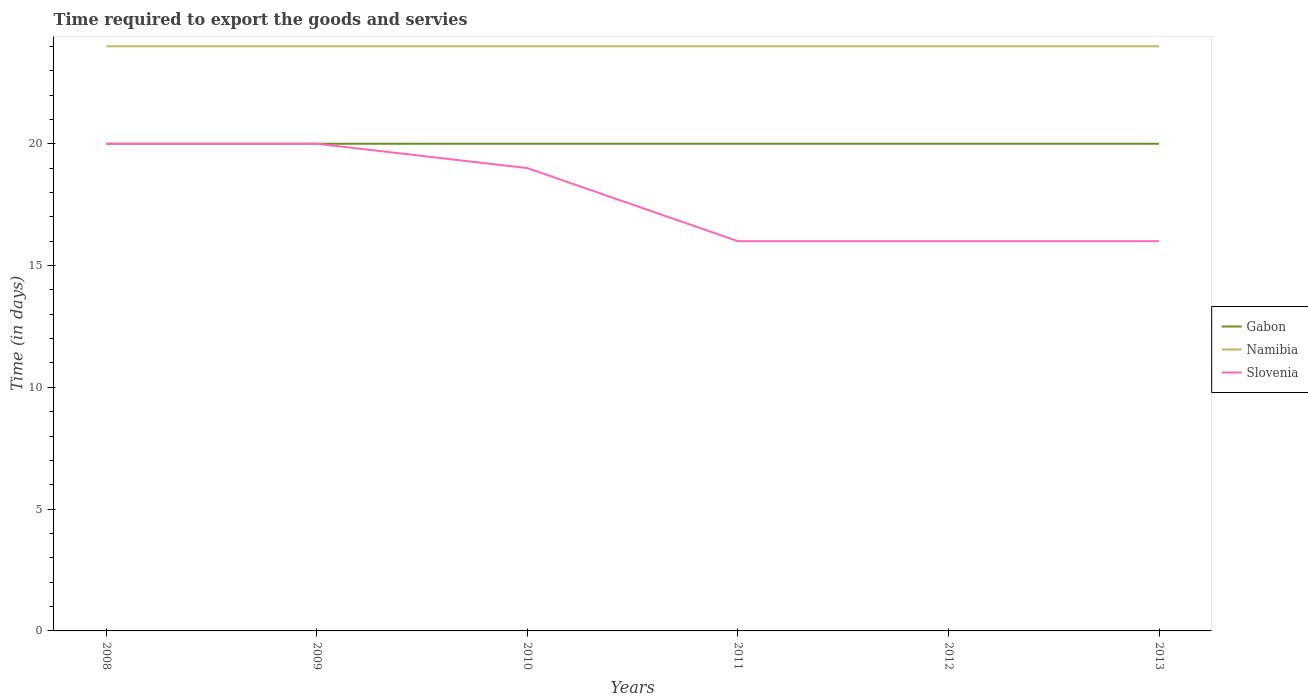Does the line corresponding to Namibia intersect with the line corresponding to Gabon?
Offer a very short reply. No. Is the number of lines equal to the number of legend labels?
Your answer should be compact. Yes. Across all years, what is the maximum number of days required to export the goods and services in Namibia?
Give a very brief answer. 24. In which year was the number of days required to export the goods and services in Namibia maximum?
Your response must be concise. 2008. What is the difference between the highest and the second highest number of days required to export the goods and services in Slovenia?
Make the answer very short. 4. How many years are there in the graph?
Offer a very short reply. 6. Does the graph contain any zero values?
Your answer should be compact. No. Where does the legend appear in the graph?
Make the answer very short. Center right. How many legend labels are there?
Provide a short and direct response. 3. What is the title of the graph?
Offer a terse response. Time required to export the goods and servies. Does "Guinea-Bissau" appear as one of the legend labels in the graph?
Make the answer very short. No. What is the label or title of the Y-axis?
Provide a succinct answer. Time (in days). What is the Time (in days) in Slovenia in 2008?
Your answer should be very brief. 20. What is the Time (in days) of Gabon in 2009?
Provide a succinct answer. 20. What is the Time (in days) of Namibia in 2009?
Your answer should be compact. 24. What is the Time (in days) in Slovenia in 2009?
Your answer should be very brief. 20. What is the Time (in days) in Gabon in 2011?
Make the answer very short. 20. What is the Time (in days) in Slovenia in 2011?
Offer a very short reply. 16. What is the Time (in days) of Namibia in 2012?
Ensure brevity in your answer.  24. What is the Time (in days) in Slovenia in 2012?
Offer a terse response. 16. What is the Time (in days) in Namibia in 2013?
Offer a very short reply. 24. What is the Time (in days) of Slovenia in 2013?
Keep it short and to the point. 16. Across all years, what is the maximum Time (in days) of Namibia?
Your answer should be very brief. 24. Across all years, what is the minimum Time (in days) in Gabon?
Ensure brevity in your answer.  20. What is the total Time (in days) of Gabon in the graph?
Your response must be concise. 120. What is the total Time (in days) of Namibia in the graph?
Give a very brief answer. 144. What is the total Time (in days) in Slovenia in the graph?
Provide a short and direct response. 107. What is the difference between the Time (in days) in Gabon in 2008 and that in 2009?
Offer a terse response. 0. What is the difference between the Time (in days) of Slovenia in 2008 and that in 2009?
Offer a very short reply. 0. What is the difference between the Time (in days) in Gabon in 2008 and that in 2010?
Provide a short and direct response. 0. What is the difference between the Time (in days) of Namibia in 2008 and that in 2010?
Ensure brevity in your answer.  0. What is the difference between the Time (in days) in Namibia in 2008 and that in 2012?
Make the answer very short. 0. What is the difference between the Time (in days) in Slovenia in 2008 and that in 2013?
Offer a terse response. 4. What is the difference between the Time (in days) of Gabon in 2009 and that in 2010?
Keep it short and to the point. 0. What is the difference between the Time (in days) of Namibia in 2009 and that in 2010?
Make the answer very short. 0. What is the difference between the Time (in days) of Gabon in 2009 and that in 2011?
Give a very brief answer. 0. What is the difference between the Time (in days) of Gabon in 2009 and that in 2012?
Make the answer very short. 0. What is the difference between the Time (in days) in Slovenia in 2009 and that in 2012?
Give a very brief answer. 4. What is the difference between the Time (in days) in Gabon in 2009 and that in 2013?
Offer a very short reply. 0. What is the difference between the Time (in days) in Slovenia in 2009 and that in 2013?
Offer a very short reply. 4. What is the difference between the Time (in days) in Gabon in 2010 and that in 2012?
Provide a short and direct response. 0. What is the difference between the Time (in days) of Namibia in 2010 and that in 2012?
Your answer should be very brief. 0. What is the difference between the Time (in days) in Slovenia in 2010 and that in 2012?
Provide a short and direct response. 3. What is the difference between the Time (in days) in Namibia in 2010 and that in 2013?
Offer a terse response. 0. What is the difference between the Time (in days) of Slovenia in 2010 and that in 2013?
Your answer should be very brief. 3. What is the difference between the Time (in days) of Namibia in 2011 and that in 2012?
Make the answer very short. 0. What is the difference between the Time (in days) in Slovenia in 2011 and that in 2012?
Your answer should be very brief. 0. What is the difference between the Time (in days) of Gabon in 2011 and that in 2013?
Keep it short and to the point. 0. What is the difference between the Time (in days) of Gabon in 2008 and the Time (in days) of Namibia in 2009?
Keep it short and to the point. -4. What is the difference between the Time (in days) of Gabon in 2008 and the Time (in days) of Namibia in 2011?
Your answer should be compact. -4. What is the difference between the Time (in days) in Namibia in 2008 and the Time (in days) in Slovenia in 2011?
Provide a short and direct response. 8. What is the difference between the Time (in days) of Namibia in 2008 and the Time (in days) of Slovenia in 2012?
Your answer should be very brief. 8. What is the difference between the Time (in days) of Gabon in 2008 and the Time (in days) of Namibia in 2013?
Keep it short and to the point. -4. What is the difference between the Time (in days) of Gabon in 2008 and the Time (in days) of Slovenia in 2013?
Your answer should be compact. 4. What is the difference between the Time (in days) of Gabon in 2009 and the Time (in days) of Namibia in 2011?
Your response must be concise. -4. What is the difference between the Time (in days) in Gabon in 2009 and the Time (in days) in Slovenia in 2011?
Your answer should be very brief. 4. What is the difference between the Time (in days) of Gabon in 2009 and the Time (in days) of Namibia in 2012?
Your answer should be very brief. -4. What is the difference between the Time (in days) in Namibia in 2009 and the Time (in days) in Slovenia in 2012?
Give a very brief answer. 8. What is the difference between the Time (in days) in Gabon in 2009 and the Time (in days) in Namibia in 2013?
Offer a terse response. -4. What is the difference between the Time (in days) in Gabon in 2010 and the Time (in days) in Namibia in 2011?
Your answer should be very brief. -4. What is the difference between the Time (in days) in Gabon in 2010 and the Time (in days) in Slovenia in 2011?
Provide a short and direct response. 4. What is the difference between the Time (in days) of Gabon in 2010 and the Time (in days) of Namibia in 2012?
Your answer should be compact. -4. What is the difference between the Time (in days) in Gabon in 2010 and the Time (in days) in Slovenia in 2012?
Make the answer very short. 4. What is the difference between the Time (in days) of Namibia in 2010 and the Time (in days) of Slovenia in 2012?
Ensure brevity in your answer.  8. What is the difference between the Time (in days) of Namibia in 2010 and the Time (in days) of Slovenia in 2013?
Ensure brevity in your answer.  8. What is the difference between the Time (in days) of Gabon in 2011 and the Time (in days) of Slovenia in 2012?
Keep it short and to the point. 4. What is the difference between the Time (in days) of Namibia in 2011 and the Time (in days) of Slovenia in 2012?
Offer a very short reply. 8. What is the difference between the Time (in days) of Gabon in 2011 and the Time (in days) of Namibia in 2013?
Offer a very short reply. -4. What is the difference between the Time (in days) of Namibia in 2011 and the Time (in days) of Slovenia in 2013?
Offer a very short reply. 8. What is the difference between the Time (in days) of Gabon in 2012 and the Time (in days) of Slovenia in 2013?
Ensure brevity in your answer.  4. What is the average Time (in days) in Gabon per year?
Keep it short and to the point. 20. What is the average Time (in days) in Namibia per year?
Provide a succinct answer. 24. What is the average Time (in days) of Slovenia per year?
Offer a terse response. 17.83. In the year 2008, what is the difference between the Time (in days) in Namibia and Time (in days) in Slovenia?
Your answer should be compact. 4. In the year 2009, what is the difference between the Time (in days) in Gabon and Time (in days) in Slovenia?
Offer a very short reply. 0. In the year 2009, what is the difference between the Time (in days) in Namibia and Time (in days) in Slovenia?
Your answer should be compact. 4. In the year 2010, what is the difference between the Time (in days) in Gabon and Time (in days) in Namibia?
Your answer should be very brief. -4. In the year 2010, what is the difference between the Time (in days) of Namibia and Time (in days) of Slovenia?
Offer a very short reply. 5. In the year 2011, what is the difference between the Time (in days) of Gabon and Time (in days) of Namibia?
Make the answer very short. -4. In the year 2011, what is the difference between the Time (in days) of Gabon and Time (in days) of Slovenia?
Provide a succinct answer. 4. In the year 2012, what is the difference between the Time (in days) in Gabon and Time (in days) in Namibia?
Your answer should be compact. -4. In the year 2012, what is the difference between the Time (in days) of Namibia and Time (in days) of Slovenia?
Provide a succinct answer. 8. In the year 2013, what is the difference between the Time (in days) in Gabon and Time (in days) in Slovenia?
Your answer should be very brief. 4. What is the ratio of the Time (in days) in Gabon in 2008 to that in 2009?
Offer a terse response. 1. What is the ratio of the Time (in days) in Namibia in 2008 to that in 2009?
Give a very brief answer. 1. What is the ratio of the Time (in days) of Slovenia in 2008 to that in 2009?
Make the answer very short. 1. What is the ratio of the Time (in days) in Gabon in 2008 to that in 2010?
Make the answer very short. 1. What is the ratio of the Time (in days) of Namibia in 2008 to that in 2010?
Offer a very short reply. 1. What is the ratio of the Time (in days) of Slovenia in 2008 to that in 2010?
Keep it short and to the point. 1.05. What is the ratio of the Time (in days) in Gabon in 2008 to that in 2011?
Provide a succinct answer. 1. What is the ratio of the Time (in days) in Namibia in 2008 to that in 2011?
Give a very brief answer. 1. What is the ratio of the Time (in days) in Slovenia in 2008 to that in 2011?
Your response must be concise. 1.25. What is the ratio of the Time (in days) of Gabon in 2008 to that in 2012?
Offer a terse response. 1. What is the ratio of the Time (in days) in Slovenia in 2008 to that in 2012?
Provide a short and direct response. 1.25. What is the ratio of the Time (in days) in Gabon in 2008 to that in 2013?
Offer a very short reply. 1. What is the ratio of the Time (in days) of Namibia in 2008 to that in 2013?
Your answer should be very brief. 1. What is the ratio of the Time (in days) in Namibia in 2009 to that in 2010?
Your answer should be compact. 1. What is the ratio of the Time (in days) of Slovenia in 2009 to that in 2010?
Offer a terse response. 1.05. What is the ratio of the Time (in days) of Gabon in 2009 to that in 2011?
Your answer should be very brief. 1. What is the ratio of the Time (in days) in Gabon in 2009 to that in 2012?
Offer a very short reply. 1. What is the ratio of the Time (in days) of Gabon in 2009 to that in 2013?
Provide a succinct answer. 1. What is the ratio of the Time (in days) of Namibia in 2009 to that in 2013?
Keep it short and to the point. 1. What is the ratio of the Time (in days) of Gabon in 2010 to that in 2011?
Your answer should be compact. 1. What is the ratio of the Time (in days) of Slovenia in 2010 to that in 2011?
Keep it short and to the point. 1.19. What is the ratio of the Time (in days) of Namibia in 2010 to that in 2012?
Keep it short and to the point. 1. What is the ratio of the Time (in days) in Slovenia in 2010 to that in 2012?
Offer a very short reply. 1.19. What is the ratio of the Time (in days) of Gabon in 2010 to that in 2013?
Make the answer very short. 1. What is the ratio of the Time (in days) in Namibia in 2010 to that in 2013?
Provide a short and direct response. 1. What is the ratio of the Time (in days) of Slovenia in 2010 to that in 2013?
Offer a terse response. 1.19. What is the ratio of the Time (in days) of Namibia in 2011 to that in 2012?
Ensure brevity in your answer.  1. What is the ratio of the Time (in days) of Gabon in 2011 to that in 2013?
Offer a terse response. 1. What is the ratio of the Time (in days) of Gabon in 2012 to that in 2013?
Ensure brevity in your answer.  1. What is the ratio of the Time (in days) of Namibia in 2012 to that in 2013?
Provide a short and direct response. 1. What is the ratio of the Time (in days) of Slovenia in 2012 to that in 2013?
Provide a short and direct response. 1. What is the difference between the highest and the lowest Time (in days) in Namibia?
Ensure brevity in your answer.  0. What is the difference between the highest and the lowest Time (in days) of Slovenia?
Your response must be concise. 4. 